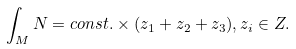Convert formula to latex. <formula><loc_0><loc_0><loc_500><loc_500>\int _ { M } N = c o n s t . \times ( z _ { 1 } + z _ { 2 } + z _ { 3 } ) , z _ { i } \in Z .</formula> 